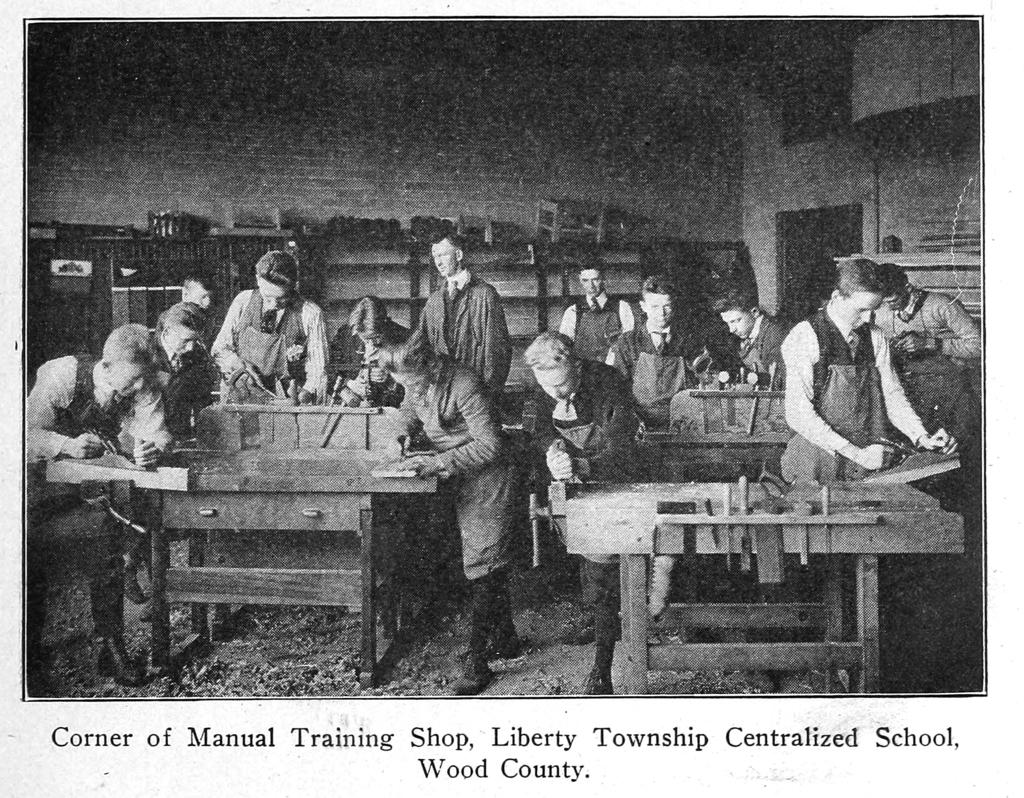What is happening in the image involving the group of people? The people in the image are standing and doing furniture work. What can be observed about the background in the image? The background wall is made of bricks. Where was the image taken? The image is a photo taken inside a hall. What type of reward is being given to the committee in the image? There is no committee or reward present in the image; it features a group of people doing furniture work in a hall with a brick wall background. 